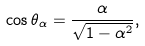<formula> <loc_0><loc_0><loc_500><loc_500>\cos \theta _ { \alpha } = \frac { \alpha } { \sqrt { 1 - \alpha ^ { 2 } } } ,</formula> 